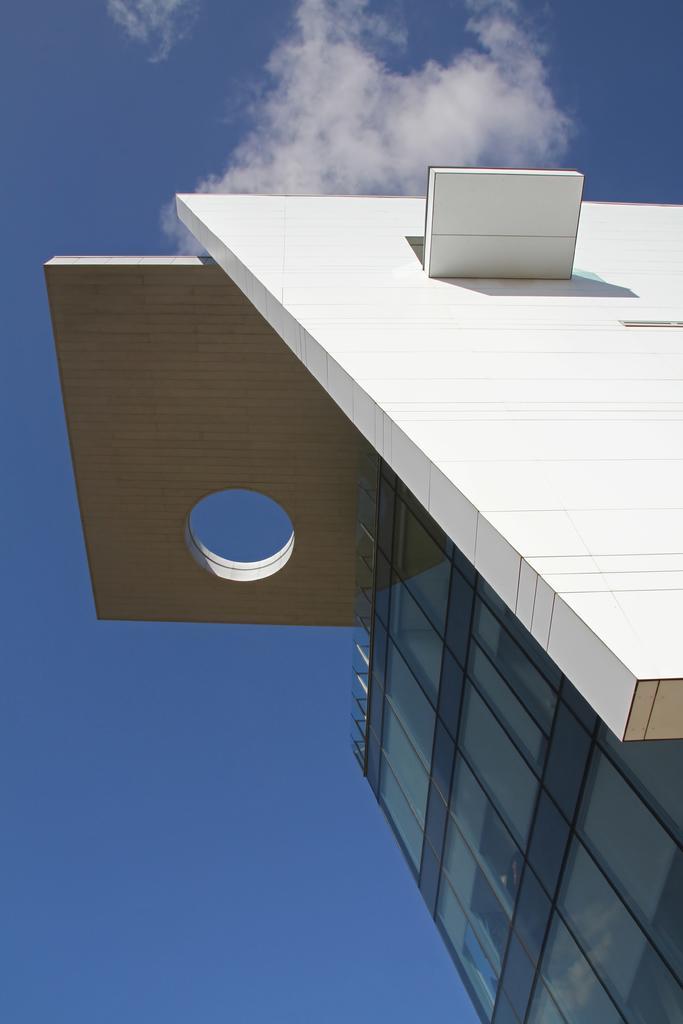Could you give a brief overview of what you see in this image? To the right side of the image there is a building. There is glass wall. At the top of the image there is sky. 